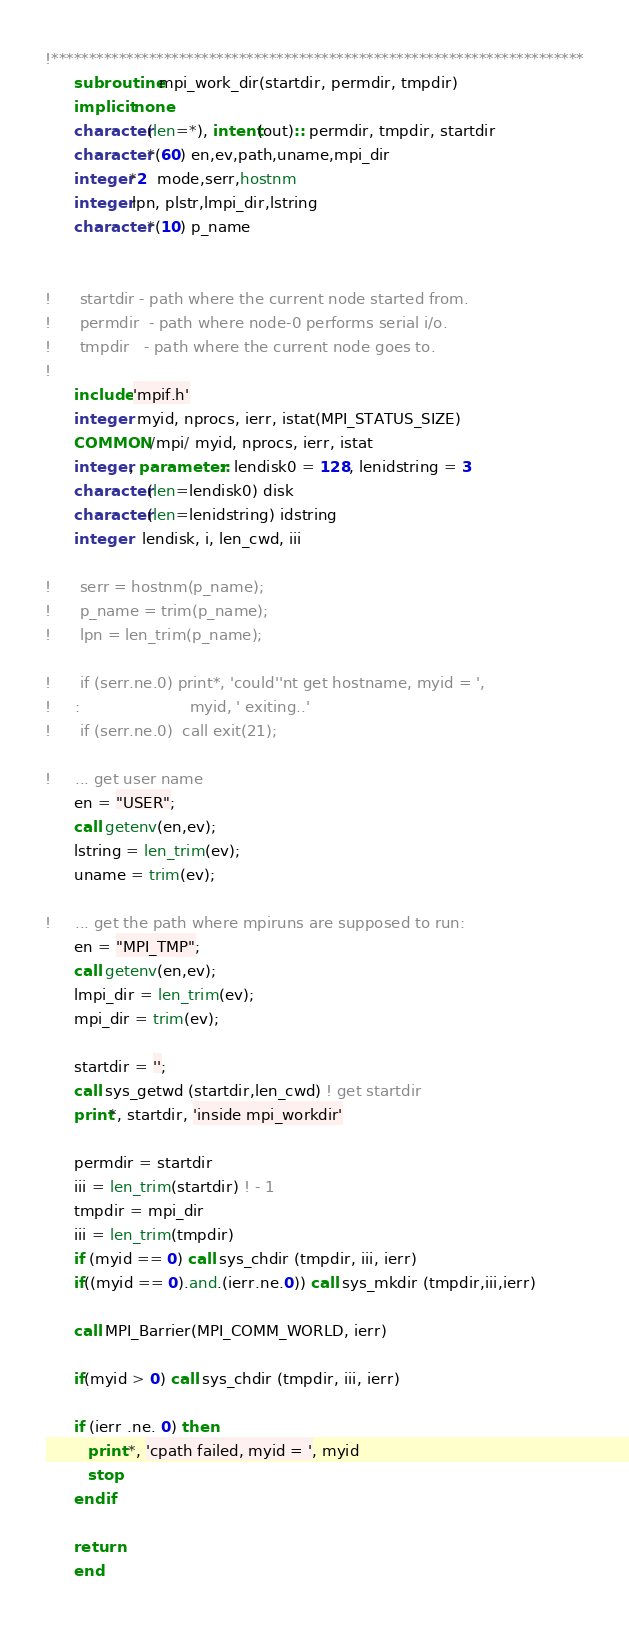Convert code to text. <code><loc_0><loc_0><loc_500><loc_500><_FORTRAN_>!***********************************************************************
      subroutine mpi_work_dir(startdir, permdir, tmpdir)
      implicit none
      character(len=*), intent(out):: permdir, tmpdir, startdir
      character*(60) en,ev,path,uname,mpi_dir
      integer*2  mode,serr,hostnm
      integer lpn, plstr,lmpi_dir,lstring
      character*(10) p_name


!      startdir - path where the current node started from.
!      permdir  - path where node-0 performs serial i/o.
!      tmpdir   - path where the current node goes to.
!
      include 'mpif.h'
      integer  myid, nprocs, ierr, istat(MPI_STATUS_SIZE)
      COMMON /mpi/ myid, nprocs, ierr, istat
      integer, parameter:: lendisk0 = 128, lenidstring = 3
      character(len=lendisk0) disk
      character(len=lenidstring) idstring
      integer   lendisk, i, len_cwd, iii

!      serr = hostnm(p_name);
!      p_name = trim(p_name);
!      lpn = len_trim(p_name);

!      if (serr.ne.0) print*, 'could''nt get hostname, myid = ',
!     :                       myid, ' exiting..'
!      if (serr.ne.0)  call exit(21);

!     ... get user name
      en = "USER";
      call getenv(en,ev);
      lstring = len_trim(ev);
      uname = trim(ev);

!     ... get the path where mpiruns are supposed to run:
      en = "MPI_TMP";
      call getenv(en,ev);
      lmpi_dir = len_trim(ev);
      mpi_dir = trim(ev);

      startdir = '';
      call sys_getwd (startdir,len_cwd) ! get startdir
      print*, startdir, 'inside mpi_workdir'

      permdir = startdir
      iii = len_trim(startdir) ! - 1
      tmpdir = mpi_dir
      iii = len_trim(tmpdir)
      if (myid == 0) call sys_chdir (tmpdir, iii, ierr)
      if((myid == 0).and.(ierr.ne.0)) call sys_mkdir (tmpdir,iii,ierr)

      call MPI_Barrier(MPI_COMM_WORLD, ierr)

      if(myid > 0) call sys_chdir (tmpdir, iii, ierr)
      
      if (ierr .ne. 0) then
         print *, 'cpath failed, myid = ', myid
         stop
      endif

      return
      end

</code> 